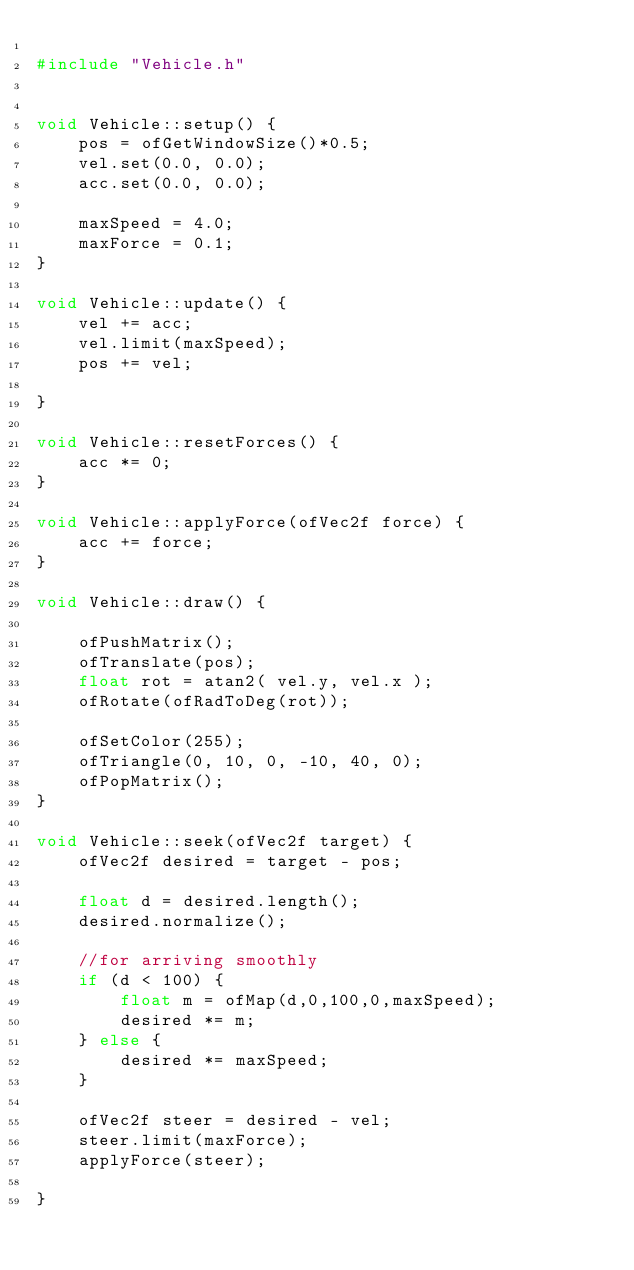Convert code to text. <code><loc_0><loc_0><loc_500><loc_500><_C++_>
#include "Vehicle.h"


void Vehicle::setup() {
    pos = ofGetWindowSize()*0.5;
    vel.set(0.0, 0.0);
    acc.set(0.0, 0.0);
    
    maxSpeed = 4.0;
    maxForce = 0.1;
}

void Vehicle::update() {
    vel += acc;
    vel.limit(maxSpeed);
    pos += vel;
    
}

void Vehicle::resetForces() {
    acc *= 0;
}

void Vehicle::applyForce(ofVec2f force) {
    acc += force;
}

void Vehicle::draw() {
    
    ofPushMatrix();
    ofTranslate(pos);
    float rot = atan2( vel.y, vel.x );
    ofRotate(ofRadToDeg(rot));
    
    ofSetColor(255);
    ofTriangle(0, 10, 0, -10, 40, 0);
    ofPopMatrix();
}

void Vehicle::seek(ofVec2f target) {
    ofVec2f desired = target - pos;
    
    float d = desired.length();
    desired.normalize();
    
    //for arriving smoothly
    if (d < 100) {
        float m = ofMap(d,0,100,0,maxSpeed);
        desired *= m;
    } else {
        desired *= maxSpeed;
    }
    
    ofVec2f steer = desired - vel;
    steer.limit(maxForce);
    applyForce(steer);
    
}</code> 